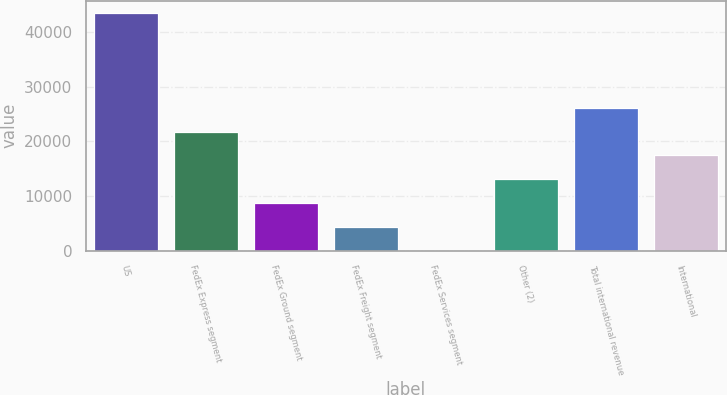Convert chart. <chart><loc_0><loc_0><loc_500><loc_500><bar_chart><fcel>US<fcel>FedEx Express segment<fcel>FedEx Ground segment<fcel>FedEx Freight segment<fcel>FedEx Services segment<fcel>Other (2)<fcel>Total international revenue<fcel>International<nl><fcel>43581<fcel>21792<fcel>8718.6<fcel>4360.8<fcel>3<fcel>13076.4<fcel>26149.8<fcel>17434.2<nl></chart> 